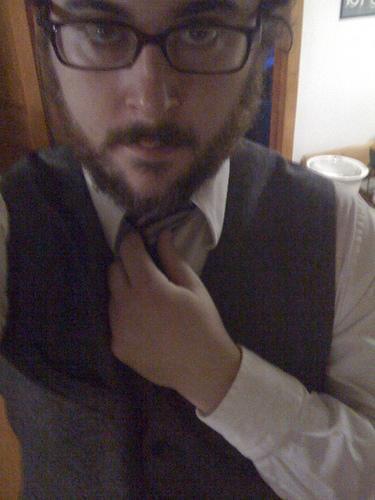What is the man adjusting?
Select the accurate answer and provide explanation: 'Answer: answer
Rationale: rationale.'
Options: Hat, belt, tie, glasses. Answer: tie.
Rationale: The man is adjusting his tie. 